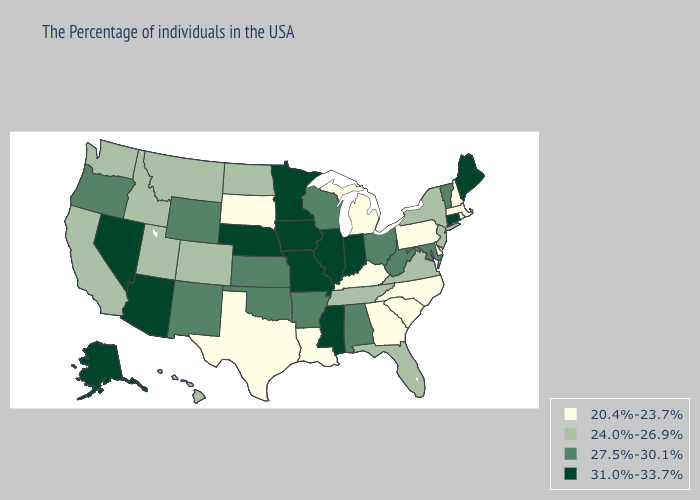What is the lowest value in the USA?
Be succinct. 20.4%-23.7%. Name the states that have a value in the range 31.0%-33.7%?
Be succinct. Maine, Connecticut, Indiana, Illinois, Mississippi, Missouri, Minnesota, Iowa, Nebraska, Arizona, Nevada, Alaska. Which states have the highest value in the USA?
Be succinct. Maine, Connecticut, Indiana, Illinois, Mississippi, Missouri, Minnesota, Iowa, Nebraska, Arizona, Nevada, Alaska. Among the states that border Wisconsin , does Iowa have the lowest value?
Quick response, please. No. What is the highest value in the MidWest ?
Answer briefly. 31.0%-33.7%. Name the states that have a value in the range 24.0%-26.9%?
Keep it brief. New York, New Jersey, Virginia, Florida, Tennessee, North Dakota, Colorado, Utah, Montana, Idaho, California, Washington, Hawaii. Does Texas have the same value as Iowa?
Be succinct. No. Which states have the lowest value in the USA?
Keep it brief. Massachusetts, Rhode Island, New Hampshire, Delaware, Pennsylvania, North Carolina, South Carolina, Georgia, Michigan, Kentucky, Louisiana, Texas, South Dakota. What is the lowest value in states that border Iowa?
Quick response, please. 20.4%-23.7%. Is the legend a continuous bar?
Keep it brief. No. What is the value of Missouri?
Short answer required. 31.0%-33.7%. Name the states that have a value in the range 27.5%-30.1%?
Answer briefly. Vermont, Maryland, West Virginia, Ohio, Alabama, Wisconsin, Arkansas, Kansas, Oklahoma, Wyoming, New Mexico, Oregon. Among the states that border Iowa , does Missouri have the highest value?
Be succinct. Yes. How many symbols are there in the legend?
Be succinct. 4. Among the states that border Montana , which have the lowest value?
Be succinct. South Dakota. 